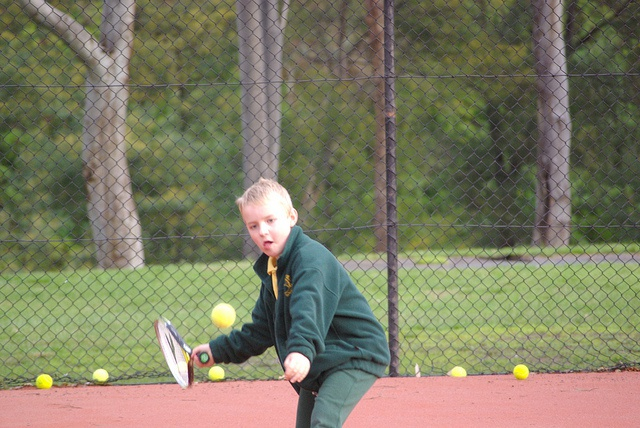Describe the objects in this image and their specific colors. I can see people in olive, teal, black, and purple tones, tennis racket in olive, white, darkgray, brown, and lightpink tones, sports ball in olive, khaki, lightyellow, and tan tones, sports ball in olive, yellow, and khaki tones, and sports ball in olive, khaki, yellow, and lightyellow tones in this image. 